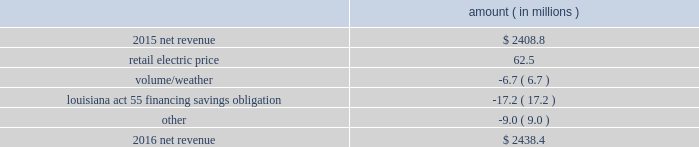The retail electric price variance is primarily due to an increase in formula rate plan revenues , implemented with the first billing cycle of march 2016 , to collect the estimated first-year revenue requirement related to the purchase of power blocks 3 and 4 of the union power station in march 2016 and a provision recorded in 2016 related to the settlement of the waterford 3 replacement steam generator prudence review proceeding .
See note 2 to the financial statements for further discussion of the formula rate plan revenues and the waterford 3 replacement steam generator prudence review proceeding .
The louisiana act 55 financing savings obligation variance results from a regulatory charge recorded in 2016 for tax savings to be shared with customers per an agreement approved by the lpsc .
The tax savings resulted from the 2010-2011 irs audit settlement on the treatment of the louisiana act 55 financing of storm costs for hurricane gustav and hurricane ike .
See note 3 to the financial statements for additional discussion of the settlement and benefit sharing .
The volume/weather variance is primarily due to the effect of less favorable weather on residential and commercial sales and decreased usage during the unbilled sales period .
The decrease was partially offset by an increase of 1237 gwh , or 4% ( 4 % ) , in industrial usage primarily due to an increase in demand from existing customers and expansion projects in the chemicals industry .
2016 compared to 2015 net revenue consists of operating revenues net of : 1 ) fuel , fuel-related expenses , and gas purchased for resale , 2 ) purchased power expenses , and 3 ) other regulatory charges .
Following is an analysis of the change in net revenue comparing 2016 to 2015 .
Amount ( in millions ) .
The retail electric price variance is primarily due to an increase in formula rate plan revenues , implemented with the first billing cycle of march 2016 , to collect the estimated first-year revenue requirement related to the purchase of power blocks 3 and 4 of the union power station .
See note 2 to the financial statements for further discussion .
The volume/weather variance is primarily due to the effect of less favorable weather on residential sales , partially offset by an increase in industrial usage and an increase in volume during the unbilled period .
The increase in industrial usage is primarily due to increased demand from new customers and expansion projects , primarily in the chemicals industry .
The louisiana act 55 financing savings obligation variance results from a regulatory charge for tax savings to be shared with customers per an agreement approved by the lpsc .
The tax savings resulted from the 2010-2011 irs audit settlement on the treatment of the louisiana act 55 financing of storm costs for hurricane gustav and hurricane ike .
See note 3 to the financial statements for additional discussion of the settlement and benefit sharing .
Included in other is a provision of $ 23 million recorded in 2016 related to the settlement of the waterford 3 replacement steam generator prudence review proceeding , offset by a provision of $ 32 million recorded in 2015 related to the uncertainty at that time associated with the resolution of the waterford 3 replacement steam generator prudence entergy louisiana , llc and subsidiaries management 2019s financial discussion and analysis .
How much higher was the net revenue in 2016 than 2015 ? ( in millions )? 
Computations: (2438.4 - 2408.8)
Answer: 29.6. 